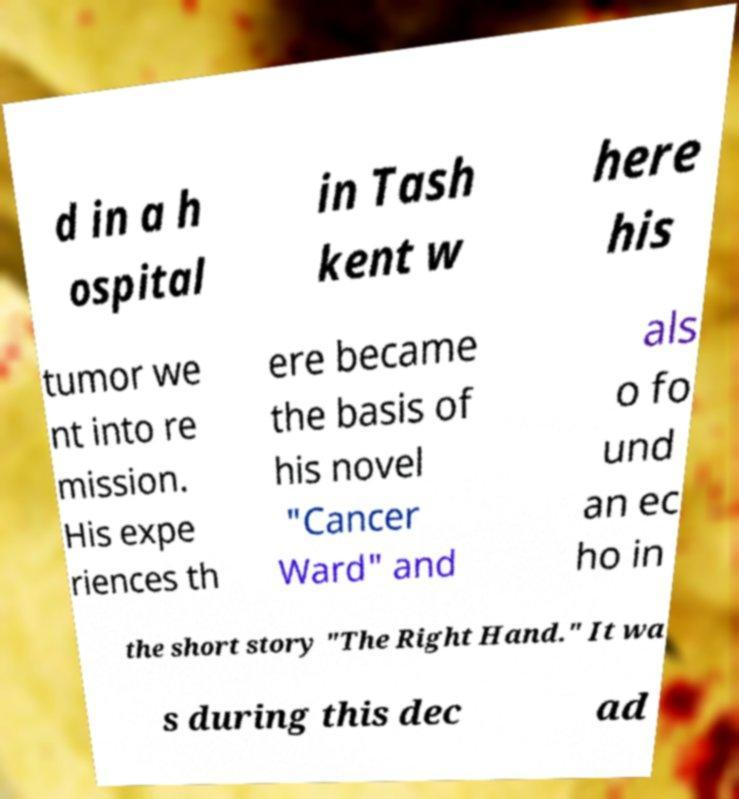Please read and relay the text visible in this image. What does it say? d in a h ospital in Tash kent w here his tumor we nt into re mission. His expe riences th ere became the basis of his novel "Cancer Ward" and als o fo und an ec ho in the short story "The Right Hand." It wa s during this dec ad 